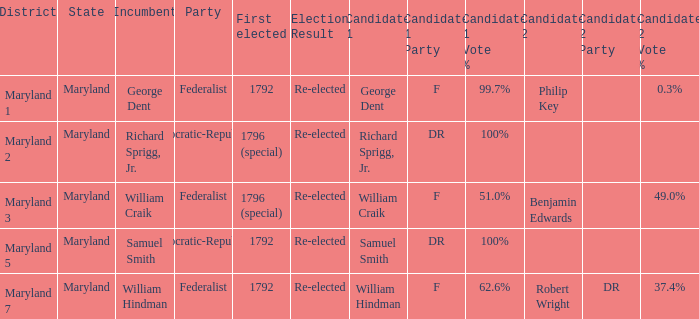Give me the full table as a dictionary. {'header': ['District', 'State', 'Incumbent', 'Party', 'First elected', 'Election Result', 'Candidate 1', 'Candidate 1 Party', 'Candidate 1 Vote %', 'Candidate 2', 'Candidate 2 Party', 'Candidate 2 Vote %'], 'rows': [['Maryland 1', 'Maryland', 'George Dent', 'Federalist', '1792', 'Re-elected', 'George Dent', 'F', '99.7%', 'Philip Key', '', '0.3%'], ['Maryland 2', 'Maryland', 'Richard Sprigg, Jr.', 'Democratic-Republican', '1796 (special)', 'Re-elected', 'Richard Sprigg, Jr.', 'DR', '100%', '', '', ''], ['Maryland 3', 'Maryland', 'William Craik', 'Federalist', '1796 (special)', 'Re-elected', 'William Craik', 'F', '51.0%', 'Benjamin Edwards', '', '49.0%'], ['Maryland 5', 'Maryland', 'Samuel Smith', 'Democratic-Republican', '1792', 'Re-elected', 'Samuel Smith', 'DR', '100%', '', '', ''], ['Maryland 7', 'Maryland', 'William Hindman', 'Federalist', '1792', 'Re-elected', 'William Hindman', 'F', '62.6%', 'Robert Wright', 'DR', '37.4%']]} In which district do the federalist party candidates william craik (f) and benjamin edwards have 51.0% and 49.0% of the votes, respectively? Maryland 3. 